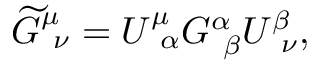<formula> <loc_0><loc_0><loc_500><loc_500>\widetilde { G } _ { \ \nu } ^ { \mu } = U _ { \ \alpha } ^ { \mu } G _ { \ \beta } ^ { \alpha } U _ { \ \nu } ^ { \beta } ,</formula> 